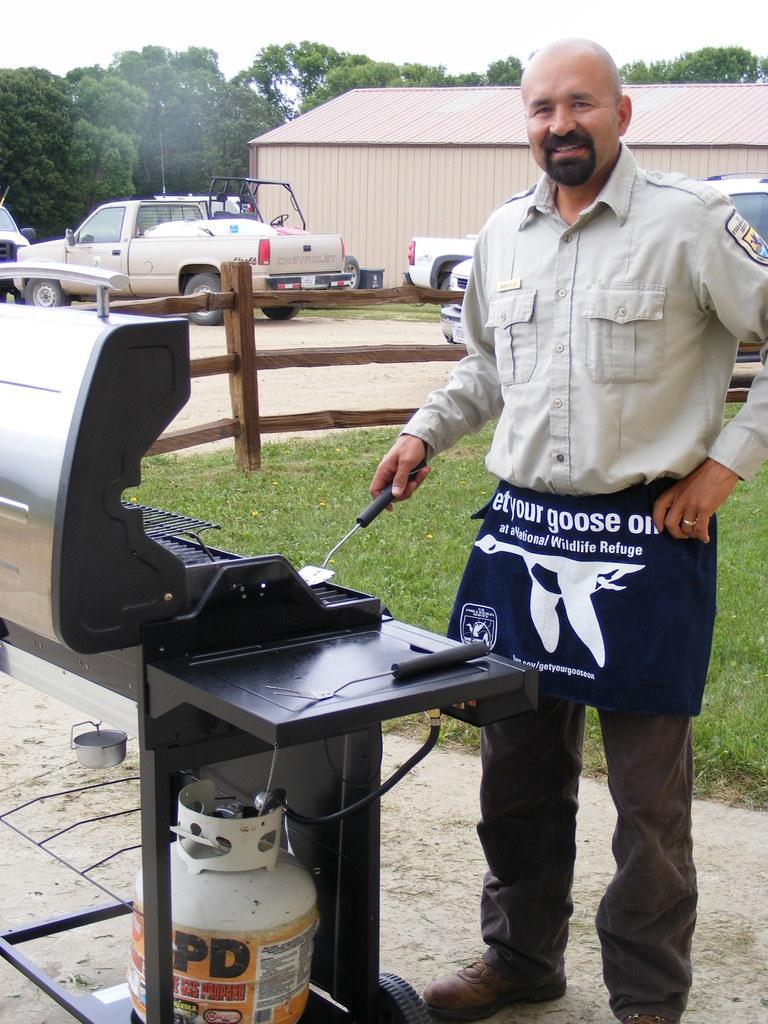<image>
Summarize the visual content of the image. A man cooking on a grill wearing and apron with a goose on it. 